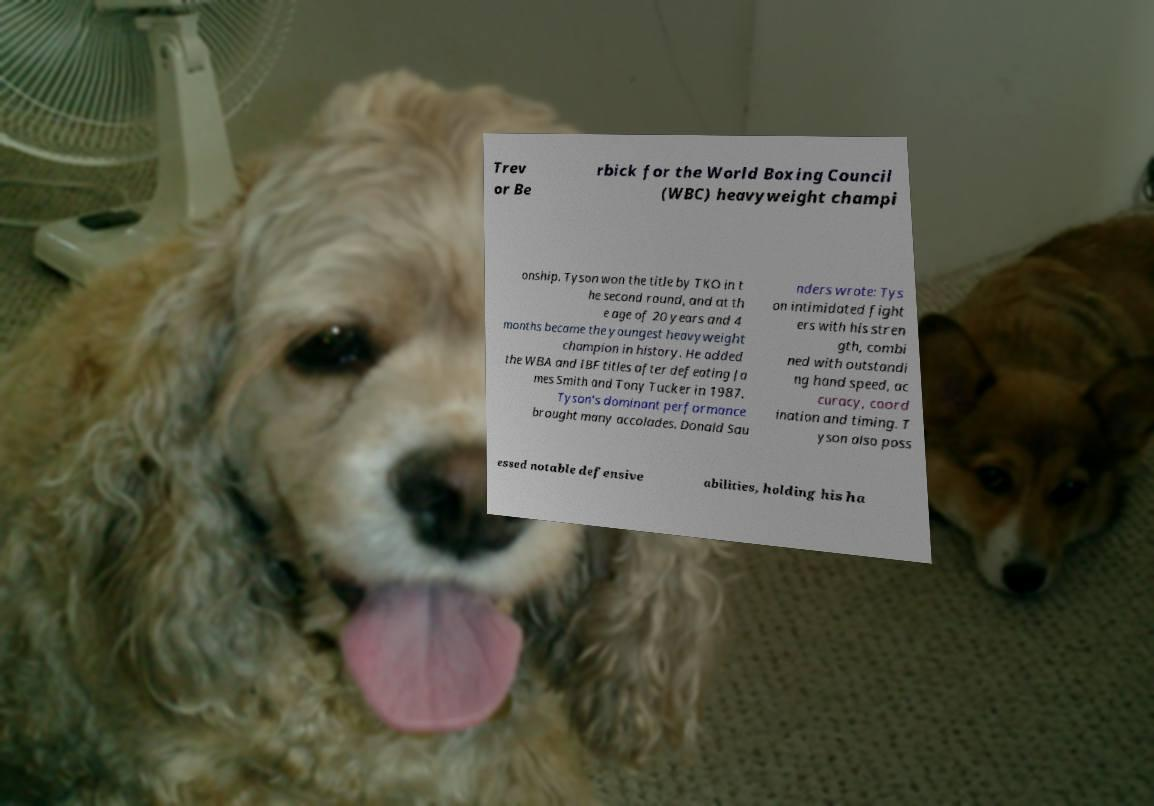Can you accurately transcribe the text from the provided image for me? Trev or Be rbick for the World Boxing Council (WBC) heavyweight champi onship. Tyson won the title by TKO in t he second round, and at th e age of 20 years and 4 months became the youngest heavyweight champion in history. He added the WBA and IBF titles after defeating Ja mes Smith and Tony Tucker in 1987. Tyson's dominant performance brought many accolades. Donald Sau nders wrote: Tys on intimidated fight ers with his stren gth, combi ned with outstandi ng hand speed, ac curacy, coord ination and timing. T yson also poss essed notable defensive abilities, holding his ha 